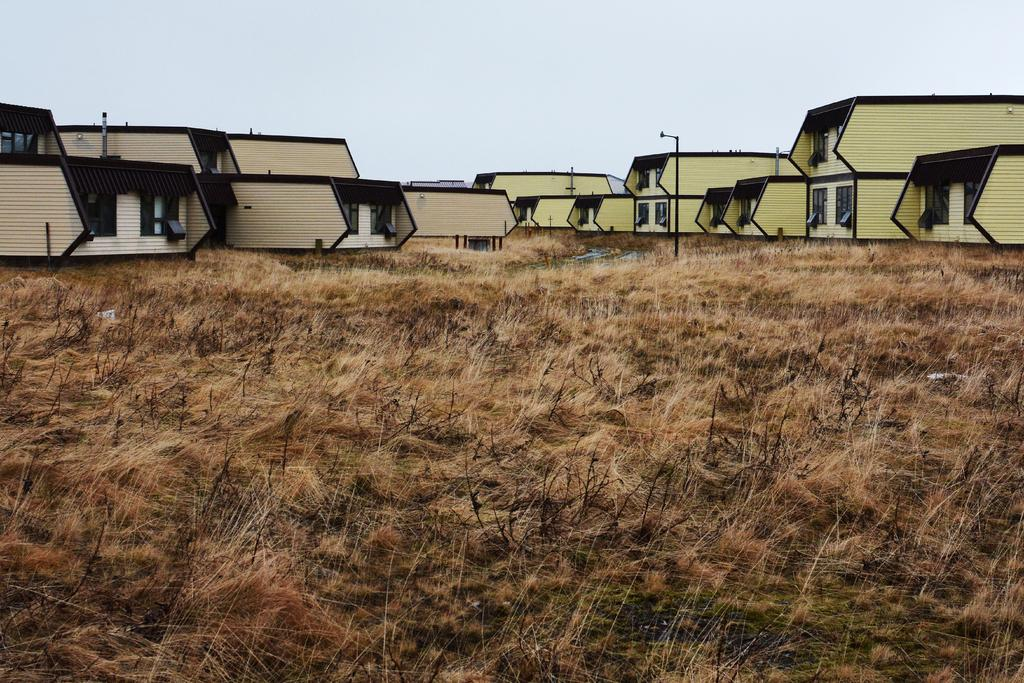What type of vegetation is present in the image? There is dry grass in the image. What can be seen in the distance behind the dry grass? There are buildings in the background of the image. What is visible at the top of the image? The sky is visible at the top of the image. What type of mint can be smelled in the image? There is no mint or any reference to smell in the image. 